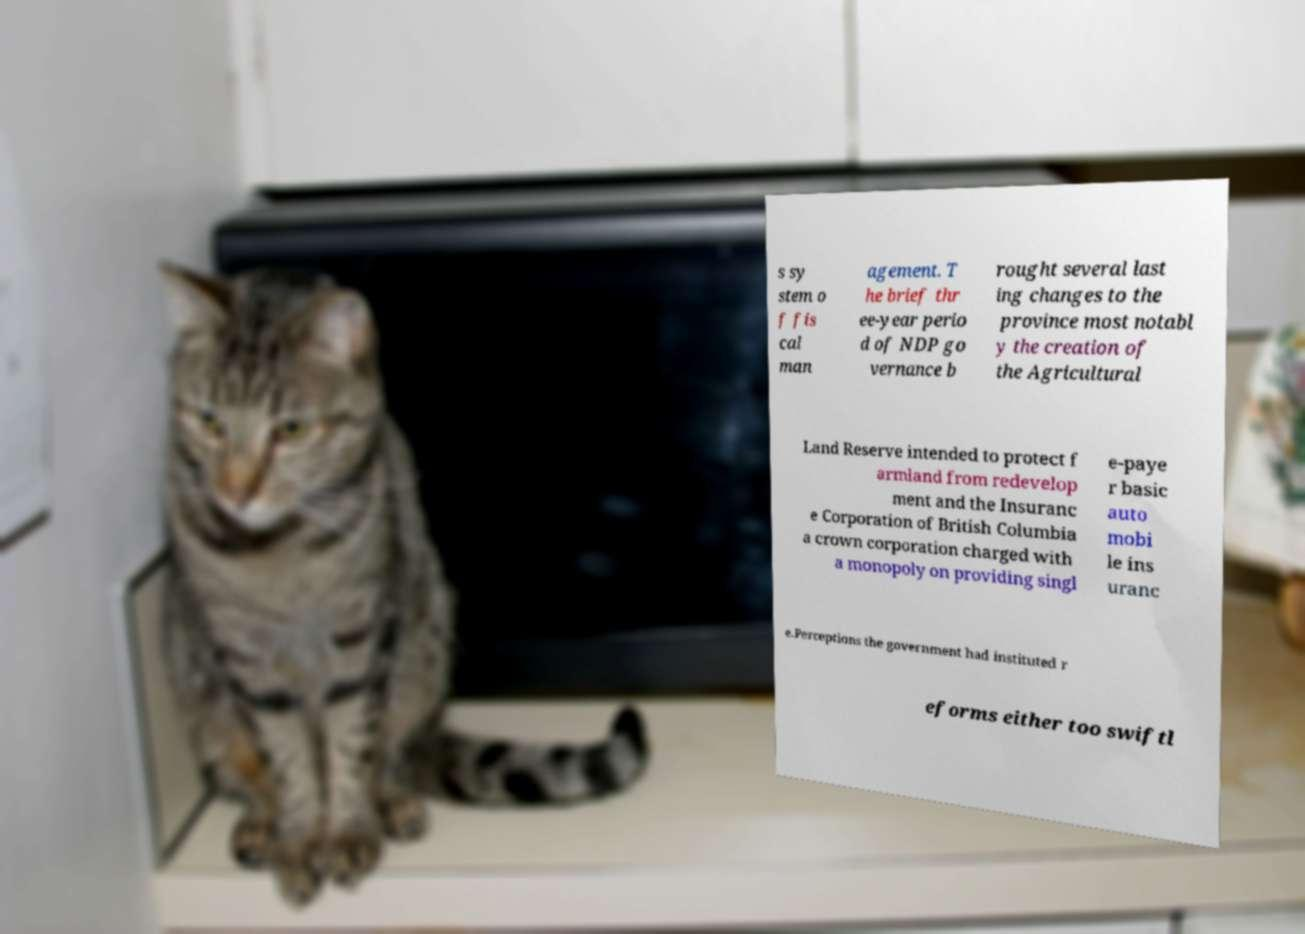I need the written content from this picture converted into text. Can you do that? s sy stem o f fis cal man agement. T he brief thr ee-year perio d of NDP go vernance b rought several last ing changes to the province most notabl y the creation of the Agricultural Land Reserve intended to protect f armland from redevelop ment and the Insuranc e Corporation of British Columbia a crown corporation charged with a monopoly on providing singl e-paye r basic auto mobi le ins uranc e.Perceptions the government had instituted r eforms either too swiftl 